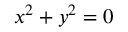<formula> <loc_0><loc_0><loc_500><loc_500>x ^ { 2 } + y ^ { 2 } = 0</formula> 